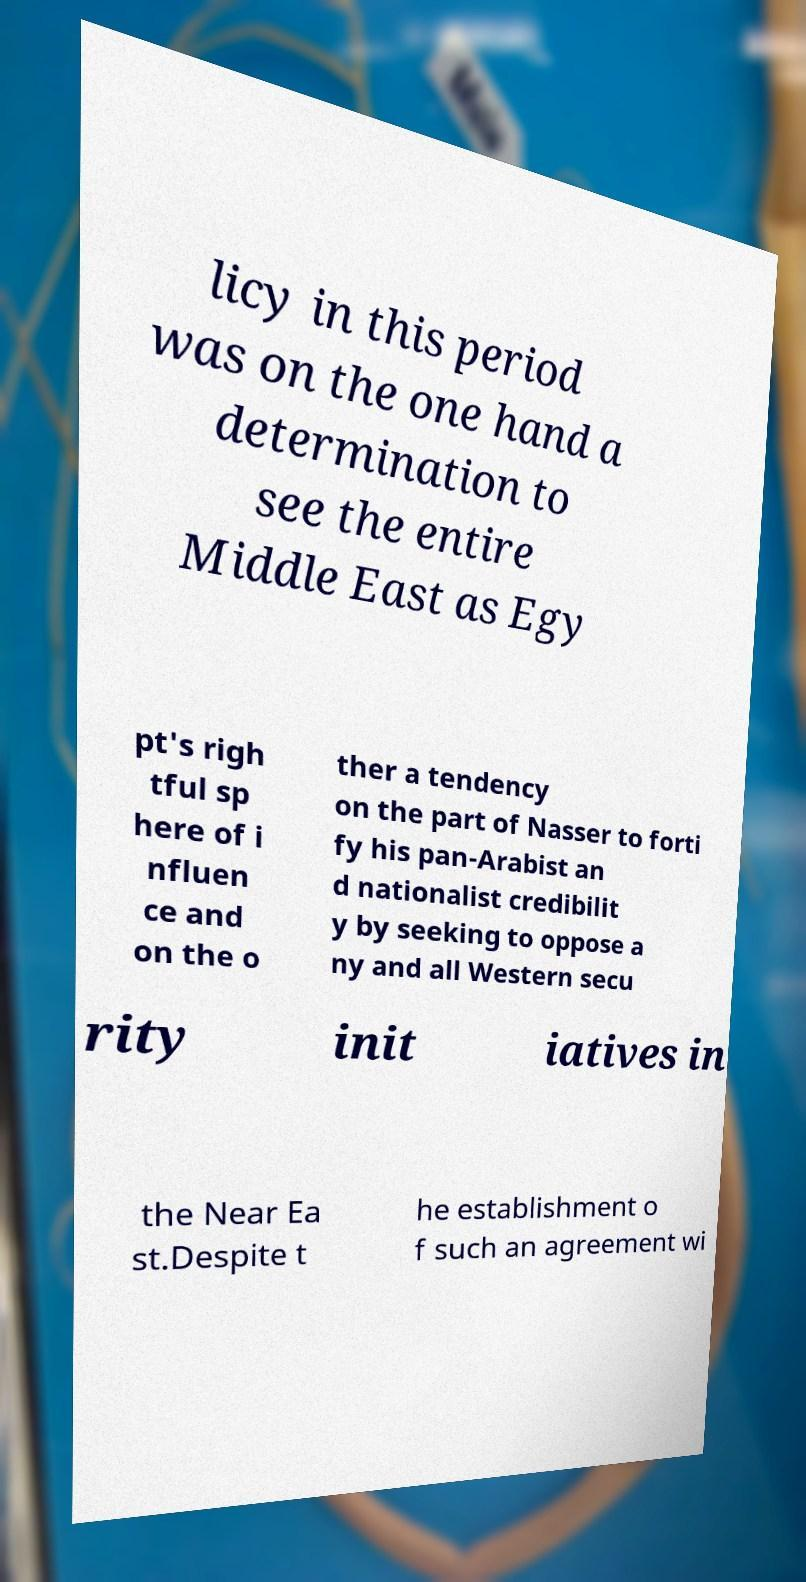I need the written content from this picture converted into text. Can you do that? licy in this period was on the one hand a determination to see the entire Middle East as Egy pt's righ tful sp here of i nfluen ce and on the o ther a tendency on the part of Nasser to forti fy his pan-Arabist an d nationalist credibilit y by seeking to oppose a ny and all Western secu rity init iatives in the Near Ea st.Despite t he establishment o f such an agreement wi 